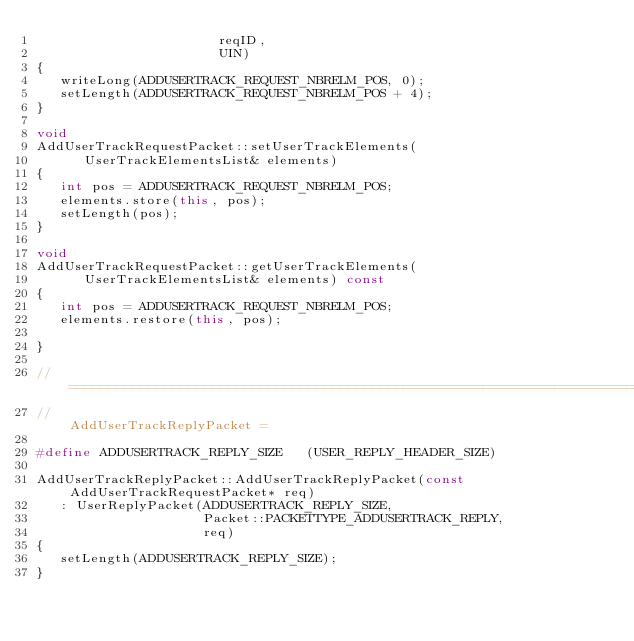<code> <loc_0><loc_0><loc_500><loc_500><_C++_>                       reqID,
                       UIN)
{
   writeLong(ADDUSERTRACK_REQUEST_NBRELM_POS, 0);
   setLength(ADDUSERTRACK_REQUEST_NBRELM_POS + 4);
}

void
AddUserTrackRequestPacket::setUserTrackElements(
      UserTrackElementsList& elements)
{
   int pos = ADDUSERTRACK_REQUEST_NBRELM_POS;
   elements.store(this, pos);
   setLength(pos);
}

void
AddUserTrackRequestPacket::getUserTrackElements(
      UserTrackElementsList& elements) const
{
   int pos = ADDUSERTRACK_REQUEST_NBRELM_POS;
   elements.restore(this, pos);
   
}

// ========================================================================
//                                                 AddUserTrackReplyPacket =

#define ADDUSERTRACK_REPLY_SIZE   (USER_REPLY_HEADER_SIZE)

AddUserTrackReplyPacket::AddUserTrackReplyPacket(const AddUserTrackRequestPacket* req)
   : UserReplyPacket(ADDUSERTRACK_REPLY_SIZE, 
                     Packet::PACKETTYPE_ADDUSERTRACK_REPLY, 
                     req)
{
   setLength(ADDUSERTRACK_REPLY_SIZE);
}

</code> 